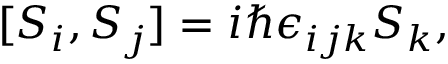<formula> <loc_0><loc_0><loc_500><loc_500>[ S _ { i } , S _ { j } ] = i \hbar { \epsilon } _ { i j k } S _ { k } ,</formula> 